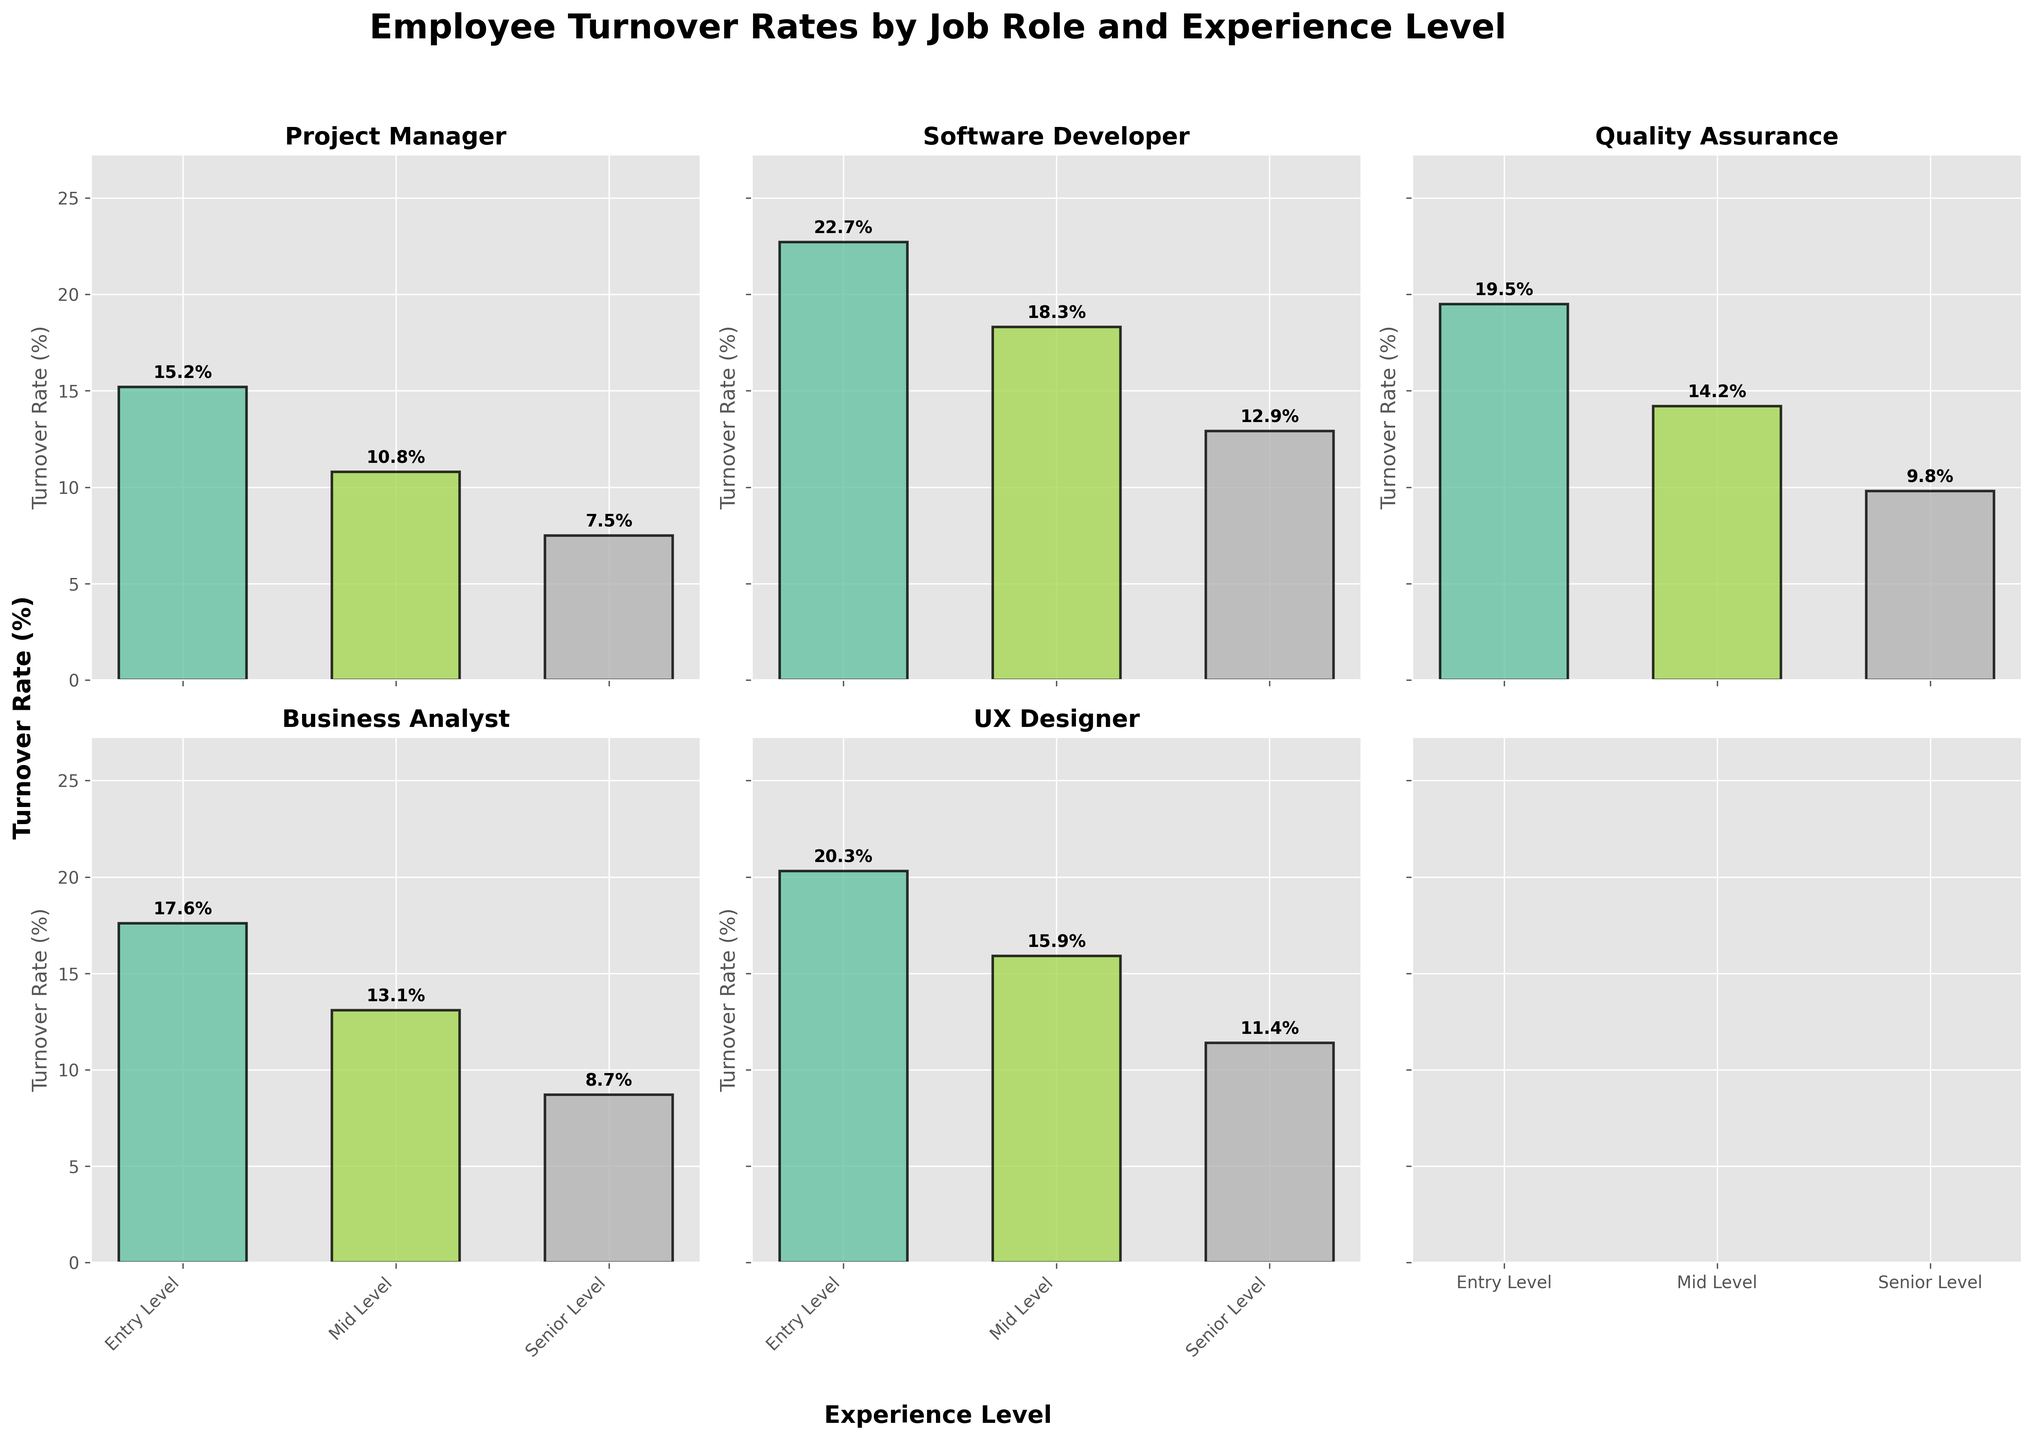What is the title of the figure? The title is usually located at the top of the figure and gives an overview of what the figure represents. In this case, from the `fig.suptitle` line in the code, the title is "Employee Turnover Rates by Job Role and Experience Level".
Answer: Employee Turnover Rates by Job Role and Experience Level What is the turnover rate for Entry Level Project Managers? Look at the bar corresponding to Entry Level Project Managers in the subplot for Project Managers. The height of the bar indicates the turnover rate, which is 15.2%.
Answer: 15.2% Which job role has the highest turnover rate at the Entry Level? Compare the heights of the bars corresponding to Entry Level across all subplots. The highest turnover rate is for Software Developers at Entry Level, which is 22.7%.
Answer: Software Developer How does the turnover rate for Senior Level UX Designers compare to Senior Level Software Developers? Look at the bars for Senior Level in the UX Designer and Software Developer subplots. The turnover rate for Senior Level UX Designers is 11.4%, while for Software Developers it is 12.9%.
Answer: UX Designers have a lower turnover rate What is the difference in turnover rates between Entry Level and Senior Level Quality Assurance roles? Find the turnover rates for Entry Level and Senior Level in the Quality Assurance subplot, which are 19.5% and 9.8% respectively. The difference is 19.5% - 9.8% = 9.7%.
Answer: 9.7% Which specific job role and experience level combination has the lowest turnover rate? Look for the shortest bar across all subplots. The turnover rate for Senior Level Project Managers is the lowest at 7.5%.
Answer: Senior Level Project Managers What is the average turnover rate for Mid Level employees across all job roles? Add the turnover rates for Mid Level employees across all job roles and divide by the number of job roles (5). (10.8 + 18.3 + 14.2 + 13.1 + 15.9) / 5 = 14.46%.
Answer: 14.46% Is there a general trend in turnover rates between different experience levels within each job role? Look at the bars within each subplot to observe the pattern. Generally, the turnover rates decrease as the experience level increases within each job role.
Answer: Turnover decreases with experience For which job role does the turnover rate decrease the most from Entry Level to Senior Level? Calculate the difference between Entry Level and Senior Level turnover rates for each job role and find the largest decrease. For Software Developers, the decrease is 22.7 - 12.9 = 9.8%.
Answer: Software Developer What are the turnover rates for Business Analysts at all experience levels? Look at the bars in the Business Analyst subplot. The turnover rates for Entry Level, Mid Level, and Senior Level are 17.6%, 13.1%, and 8.7% respectively.
Answer: 17.6%, 13.1%, 8.7% 